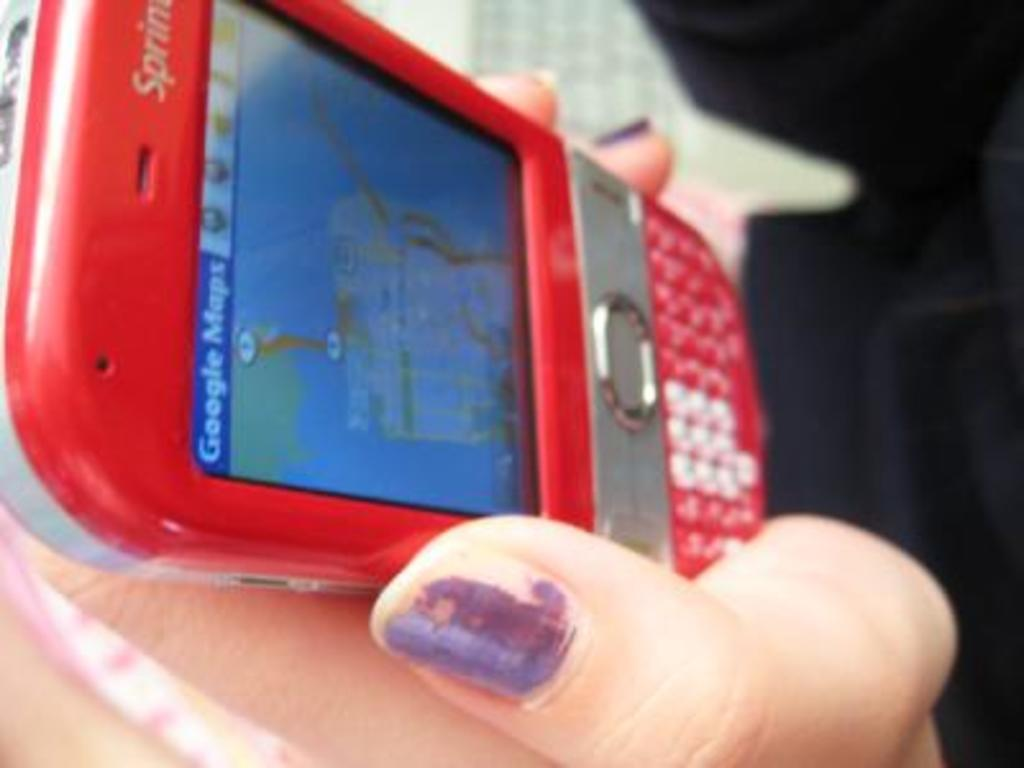Provide a one-sentence caption for the provided image. a lady interacting with Google Maps on the phone. 